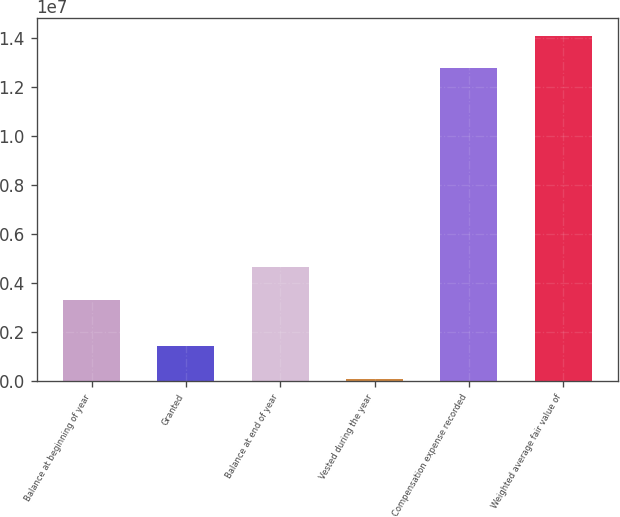<chart> <loc_0><loc_0><loc_500><loc_500><bar_chart><fcel>Balance at beginning of year<fcel>Granted<fcel>Balance at end of year<fcel>Vested during the year<fcel>Compensation expense recorded<fcel>Weighted average fair value of<nl><fcel>3.29822e+06<fcel>1.42695e+06<fcel>4.63305e+06<fcel>92114<fcel>1.27577e+07<fcel>1.40925e+07<nl></chart> 